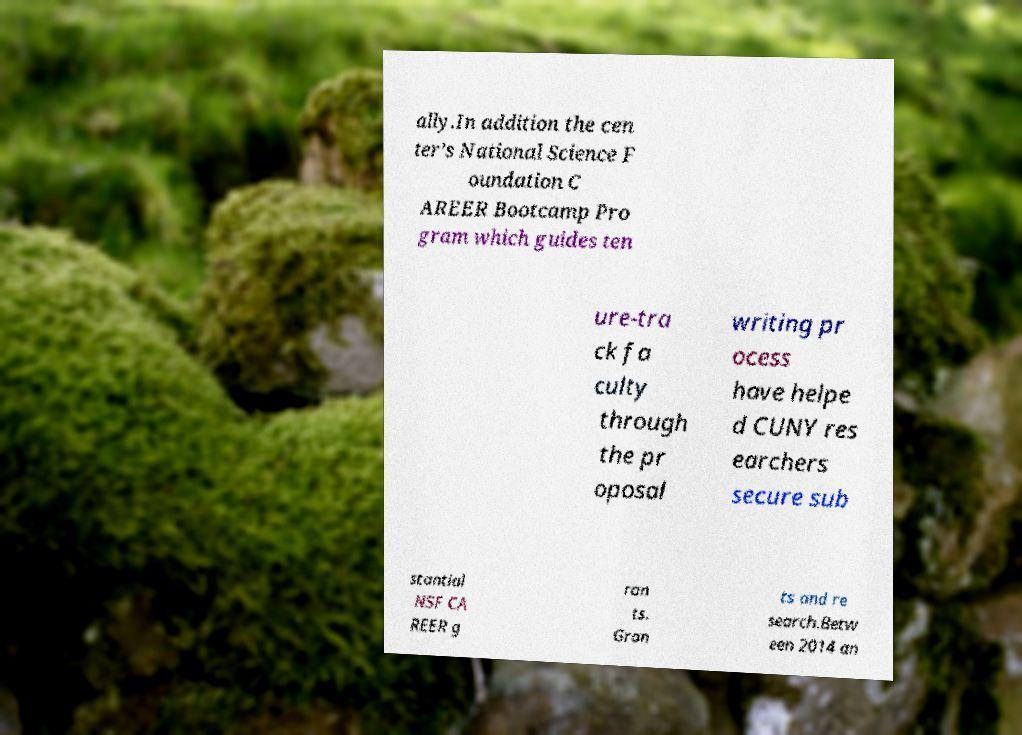What messages or text are displayed in this image? I need them in a readable, typed format. ally.In addition the cen ter’s National Science F oundation C AREER Bootcamp Pro gram which guides ten ure-tra ck fa culty through the pr oposal writing pr ocess have helpe d CUNY res earchers secure sub stantial NSF CA REER g ran ts. Gran ts and re search.Betw een 2014 an 